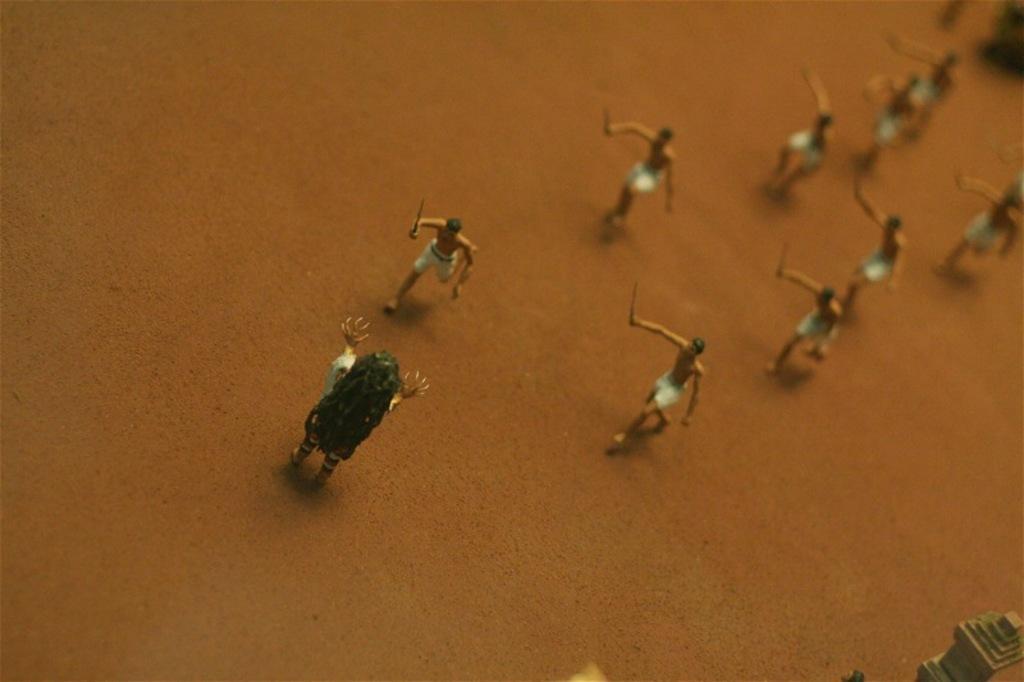Describe this image in one or two sentences. As we can see in the image, there are lot of toys. The toys are in the shape of running. The toys are on table. 